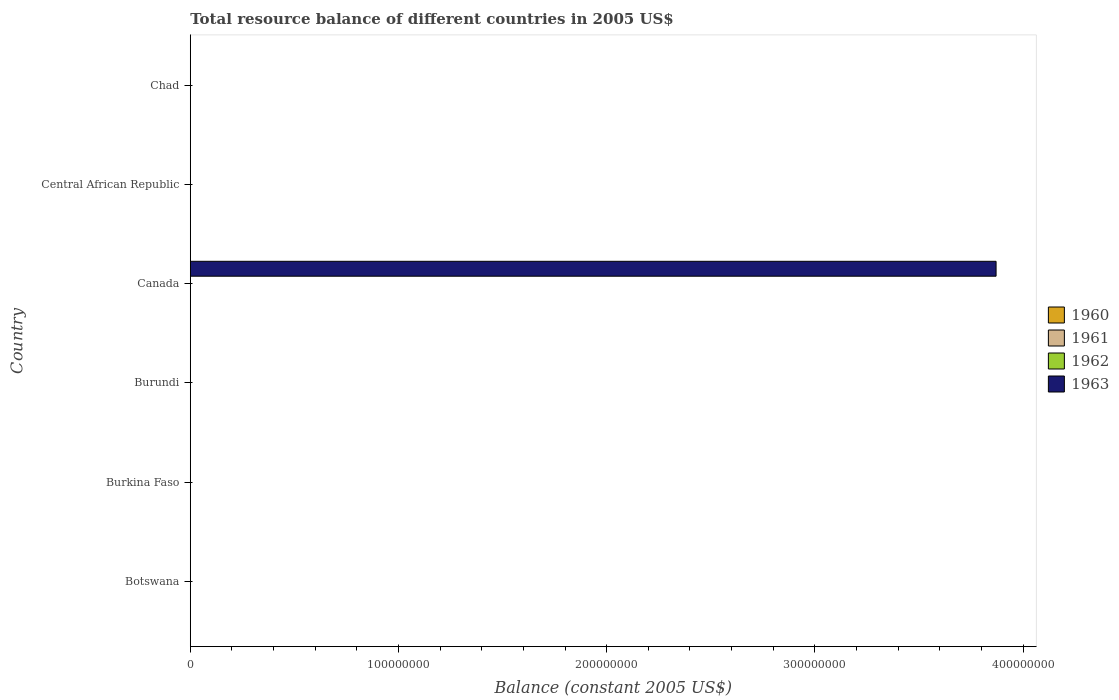How many bars are there on the 2nd tick from the bottom?
Provide a succinct answer. 0. What is the label of the 1st group of bars from the top?
Your answer should be compact. Chad. What is the total resource balance in 1962 in Burundi?
Give a very brief answer. 0. Across all countries, what is the maximum total resource balance in 1963?
Provide a short and direct response. 3.87e+08. Across all countries, what is the minimum total resource balance in 1960?
Provide a short and direct response. 0. What is the average total resource balance in 1962 per country?
Your answer should be compact. 0. In how many countries, is the total resource balance in 1960 greater than 120000000 US$?
Your response must be concise. 0. What is the difference between the highest and the lowest total resource balance in 1963?
Provide a short and direct response. 3.87e+08. Is it the case that in every country, the sum of the total resource balance in 1961 and total resource balance in 1960 is greater than the sum of total resource balance in 1963 and total resource balance in 1962?
Your answer should be very brief. No. Is it the case that in every country, the sum of the total resource balance in 1963 and total resource balance in 1960 is greater than the total resource balance in 1962?
Your answer should be compact. No. How many bars are there?
Keep it short and to the point. 1. Are all the bars in the graph horizontal?
Your answer should be very brief. Yes. How many countries are there in the graph?
Your answer should be very brief. 6. What is the difference between two consecutive major ticks on the X-axis?
Your response must be concise. 1.00e+08. Are the values on the major ticks of X-axis written in scientific E-notation?
Keep it short and to the point. No. Does the graph contain any zero values?
Offer a terse response. Yes. Does the graph contain grids?
Your response must be concise. No. How many legend labels are there?
Ensure brevity in your answer.  4. What is the title of the graph?
Your answer should be very brief. Total resource balance of different countries in 2005 US$. Does "1982" appear as one of the legend labels in the graph?
Ensure brevity in your answer.  No. What is the label or title of the X-axis?
Ensure brevity in your answer.  Balance (constant 2005 US$). What is the Balance (constant 2005 US$) of 1960 in Botswana?
Keep it short and to the point. 0. What is the Balance (constant 2005 US$) in 1962 in Botswana?
Provide a short and direct response. 0. What is the Balance (constant 2005 US$) in 1962 in Burkina Faso?
Your response must be concise. 0. What is the Balance (constant 2005 US$) of 1961 in Burundi?
Your answer should be compact. 0. What is the Balance (constant 2005 US$) of 1962 in Burundi?
Give a very brief answer. 0. What is the Balance (constant 2005 US$) of 1963 in Burundi?
Give a very brief answer. 0. What is the Balance (constant 2005 US$) in 1961 in Canada?
Your answer should be very brief. 0. What is the Balance (constant 2005 US$) in 1962 in Canada?
Keep it short and to the point. 0. What is the Balance (constant 2005 US$) of 1963 in Canada?
Your answer should be compact. 3.87e+08. What is the Balance (constant 2005 US$) in 1961 in Chad?
Offer a terse response. 0. What is the Balance (constant 2005 US$) in 1962 in Chad?
Give a very brief answer. 0. What is the Balance (constant 2005 US$) of 1963 in Chad?
Keep it short and to the point. 0. Across all countries, what is the maximum Balance (constant 2005 US$) of 1963?
Provide a succinct answer. 3.87e+08. What is the total Balance (constant 2005 US$) of 1961 in the graph?
Your response must be concise. 0. What is the total Balance (constant 2005 US$) of 1962 in the graph?
Your answer should be compact. 0. What is the total Balance (constant 2005 US$) in 1963 in the graph?
Offer a terse response. 3.87e+08. What is the average Balance (constant 2005 US$) in 1961 per country?
Offer a very short reply. 0. What is the average Balance (constant 2005 US$) of 1962 per country?
Ensure brevity in your answer.  0. What is the average Balance (constant 2005 US$) in 1963 per country?
Your answer should be very brief. 6.45e+07. What is the difference between the highest and the lowest Balance (constant 2005 US$) of 1963?
Your answer should be very brief. 3.87e+08. 